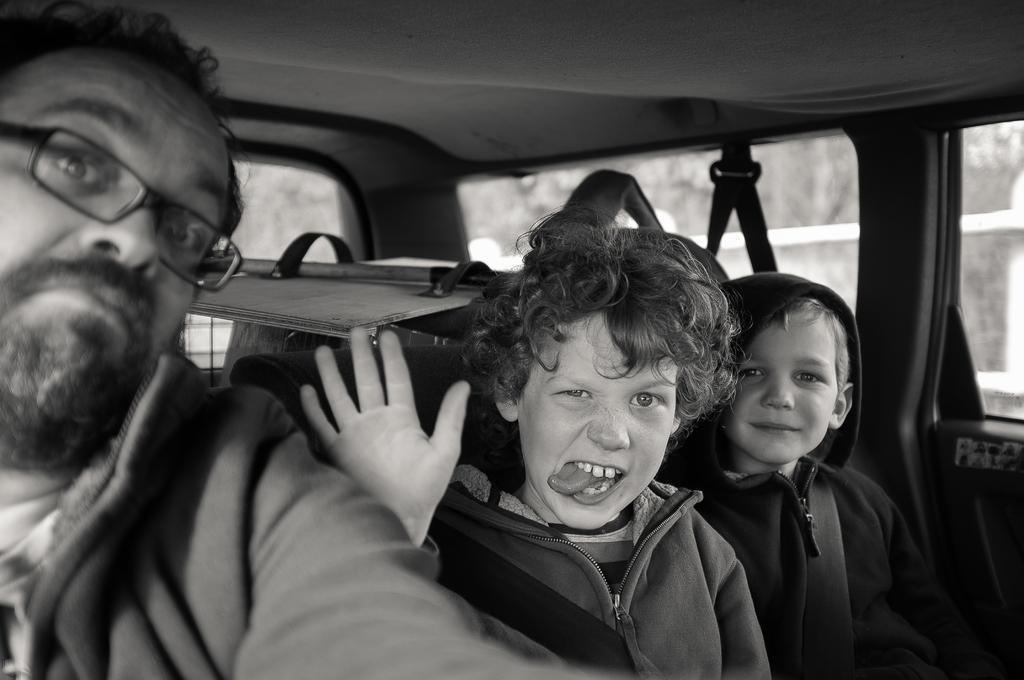How would you summarize this image in a sentence or two? This is a black and white picture. In this picture we can see three persons sitting inside a vehicle and giving a pose to the camera. This man wore spectacles. 